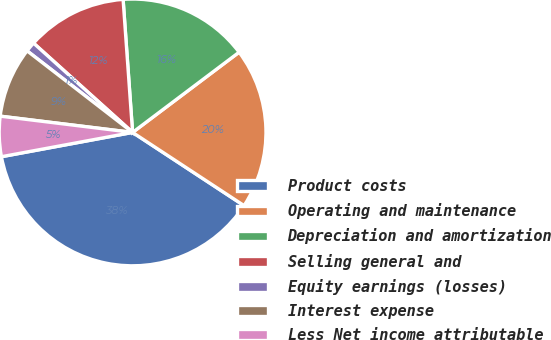Convert chart to OTSL. <chart><loc_0><loc_0><loc_500><loc_500><pie_chart><fcel>Product costs<fcel>Operating and maintenance<fcel>Depreciation and amortization<fcel>Selling general and<fcel>Equity earnings (losses)<fcel>Interest expense<fcel>Less Net income attributable<nl><fcel>37.84%<fcel>19.52%<fcel>15.86%<fcel>12.19%<fcel>1.2%<fcel>8.53%<fcel>4.86%<nl></chart> 